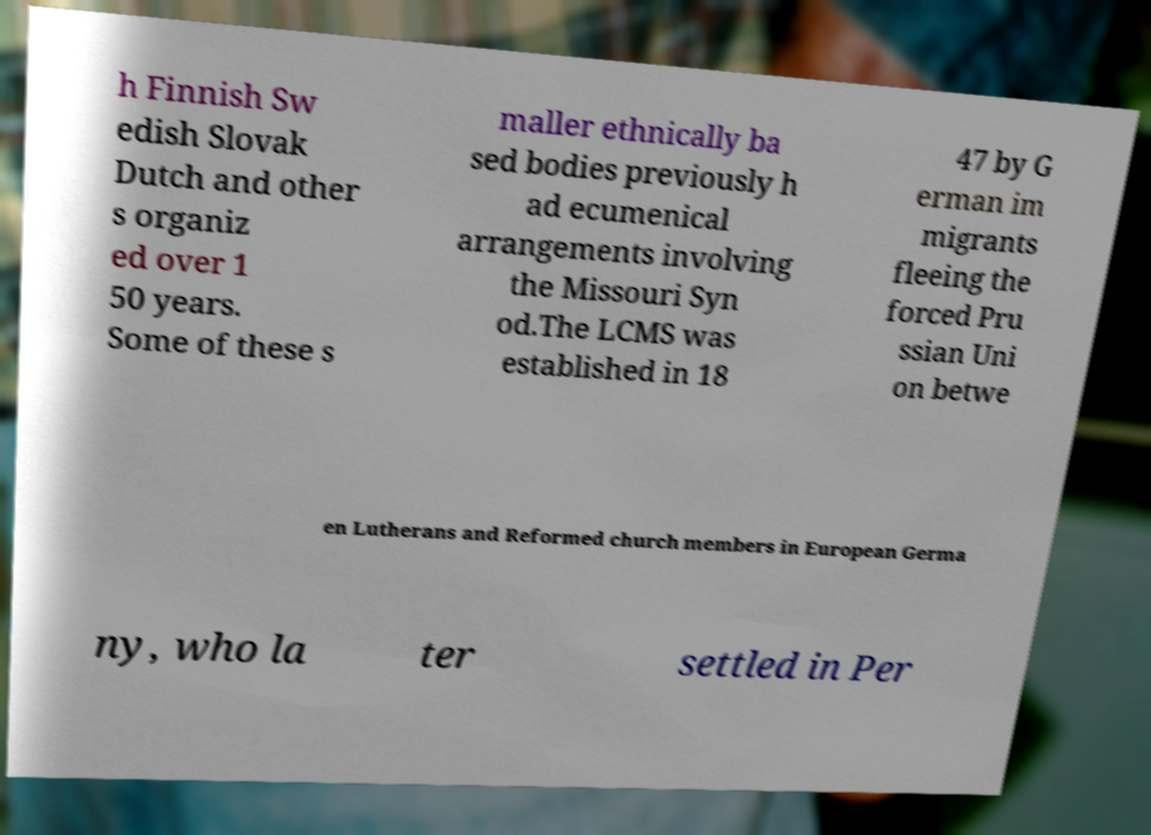Could you assist in decoding the text presented in this image and type it out clearly? h Finnish Sw edish Slovak Dutch and other s organiz ed over 1 50 years. Some of these s maller ethnically ba sed bodies previously h ad ecumenical arrangements involving the Missouri Syn od.The LCMS was established in 18 47 by G erman im migrants fleeing the forced Pru ssian Uni on betwe en Lutherans and Reformed church members in European Germa ny, who la ter settled in Per 